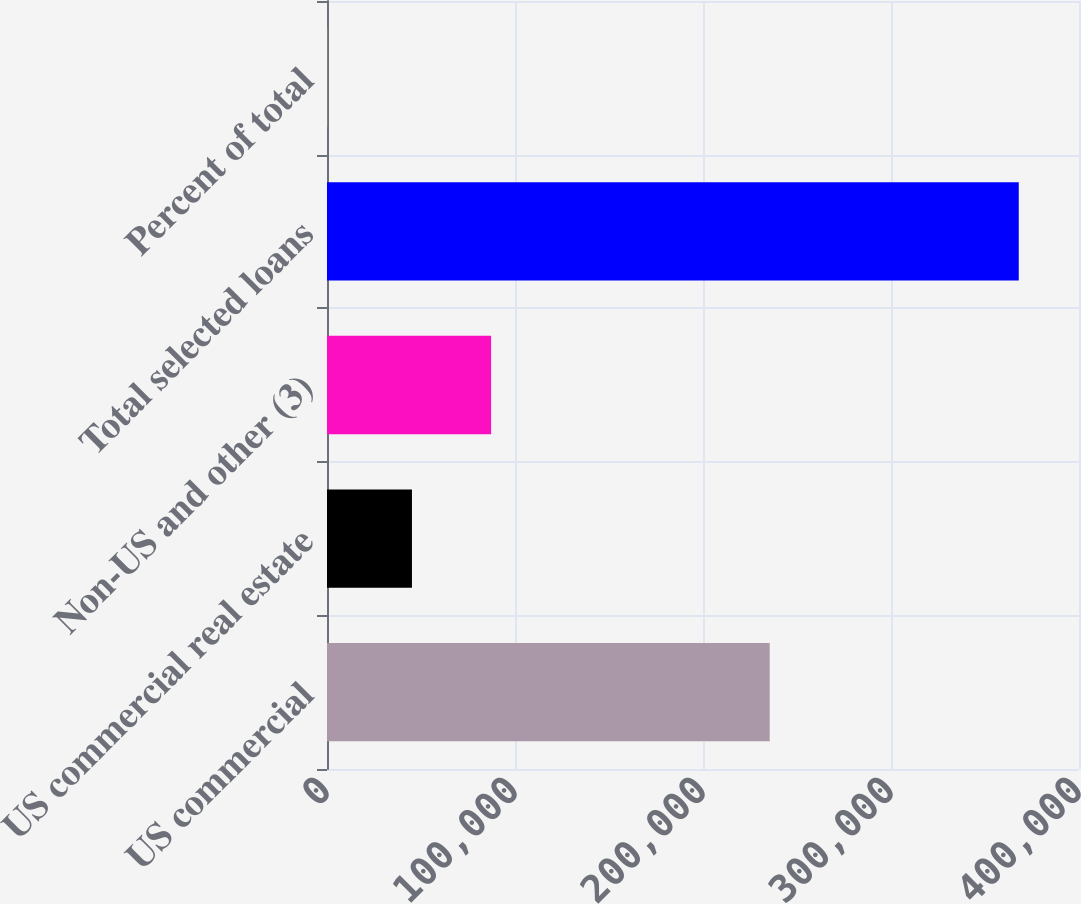Convert chart. <chart><loc_0><loc_0><loc_500><loc_500><bar_chart><fcel>US commercial<fcel>US commercial real estate<fcel>Non-US and other (3)<fcel>Total selected loans<fcel>Percent of total<nl><fcel>235477<fcel>45187<fcel>87291<fcel>367955<fcel>100<nl></chart> 